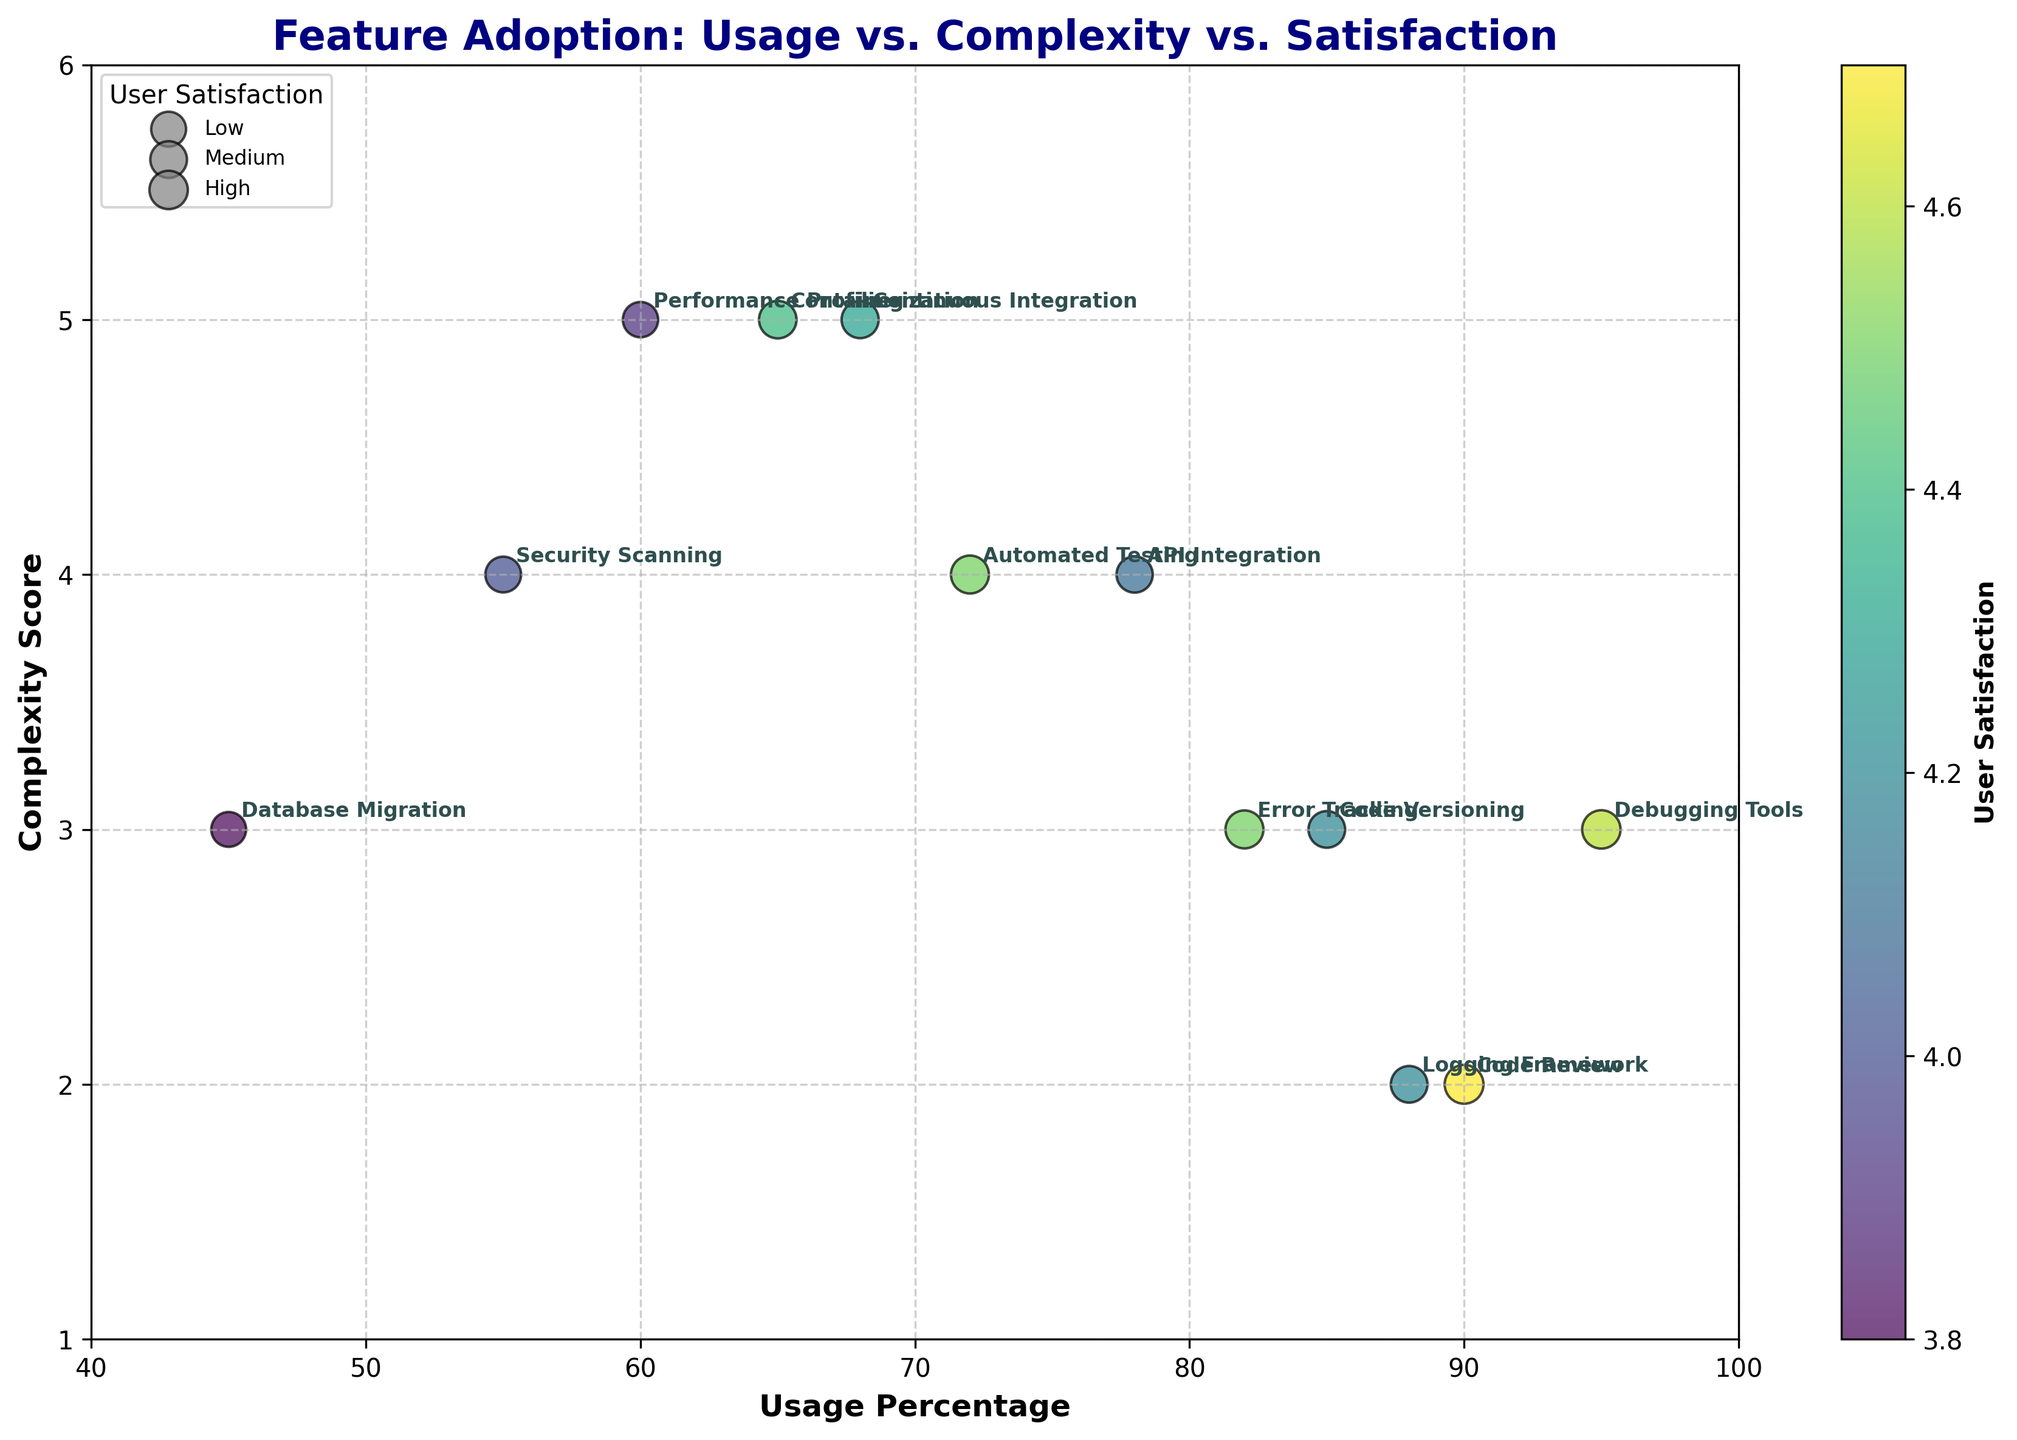What is the title of the plot? The title is typically located at the top of the plot. In this case, the title is “Feature Adoption: Usage vs. Complexity vs. Satisfaction” is clearly stated.
Answer: Feature Adoption: Usage vs. Complexity vs. Satisfaction How many features were analyzed in the plot? Each feature is represented by a data point in the scatter plot, with labels such as "Code Review" or "Debugging Tools". Counting these labels yields 12 features.
Answer: 12 Which feature has the highest user satisfaction score? The color bar indicates that user satisfaction is represented by the color intensity. The feature positioned above others in color intensity (darkest color) corresponds to "Code Review".
Answer: Code Review Which feature has the lowest usage percentage? Usage percentage is indicated on the x-axis. The point with the lowest x-axis value is "Database Migration".
Answer: Database Migration What is the complexity score for the feature with the highest user satisfaction? "Code Review" has the highest user satisfaction. Its position on the y-axis represents the complexity score, which is 2.
Answer: 2 What is the average complexity score of all features? Summing up all complexity scores (3+4+5+2+3+4+5+4+3+5+2+3 = 39) and dividing by the total number of features (12), we get the average complexity score: 39 / 12 = 3.25.
Answer: 3.25 What are the highest and lowest complexity scores among the features? By observing the y-axis, the highest score is 5, observed in several features like "Continuous Integration" and "Performance Profiling". The lowest score is 2, seen in "Code Review" and "Logging Framework".
Answer: Highest: 5, Lowest: 2 Which feature has the highest usage percentage among those with a complexity score of 3? Looking at features with a complexity score of 3 (along y-axis), "Debugging Tools" has the highest usage percentage (95%) among them.
Answer: Debugging Tools Is there a correlation between usage percentage and complexity score evident in the plot? Observing the scatter plot, there doesn't appear to be a strong pattern or trend correlating usage percentage (x-axis) and complexity score (y-axis). There is a mix of high and low usage percentages across all complexity scores.
Answer: No Which features have both high usage percentages (above 80%) and high complexity scores (above 3)? By examining the x-axis for usage percentages above 80% and the y-axis for complexity scores above 3, only "Automated Testing" fits these criteria.
Answer: Automated Testing 